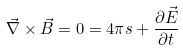<formula> <loc_0><loc_0><loc_500><loc_500>\vec { \nabla } \times \vec { B } = 0 = 4 \pi s + \frac { \partial \vec { E } } { \partial t }</formula> 